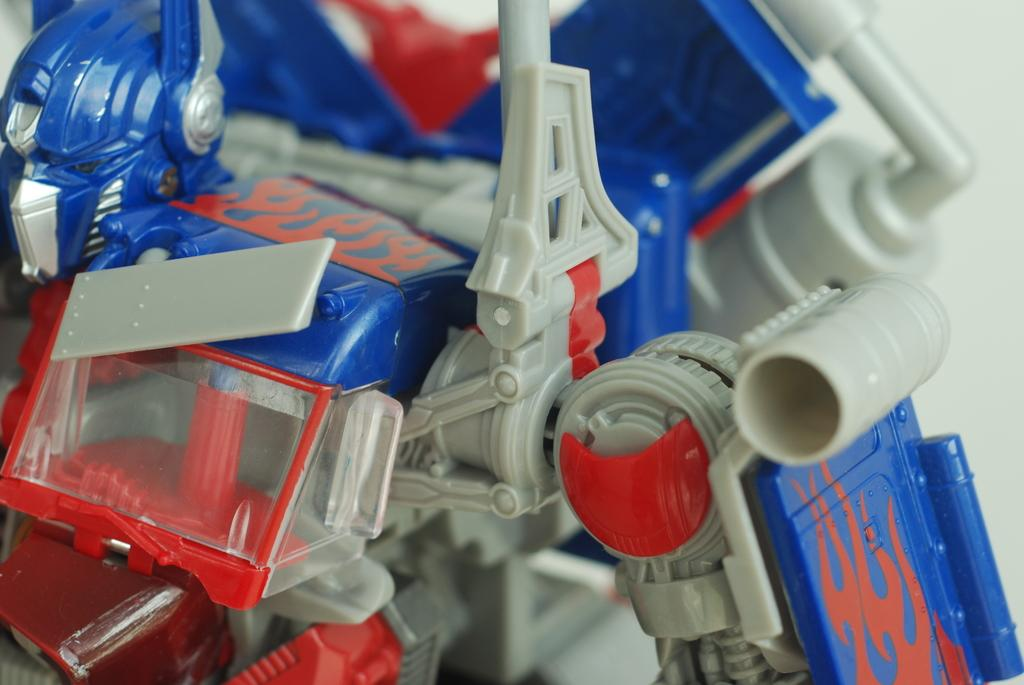What objects can be seen in the image? There are toys in the image. Can you describe the background of the image? The background of the image is blurred. Is there a servant holding the toys in the image? There is no servant present in the image. What part of the body can be seen touching the toys in the image? There are no body parts visible touching the toys in the image. 